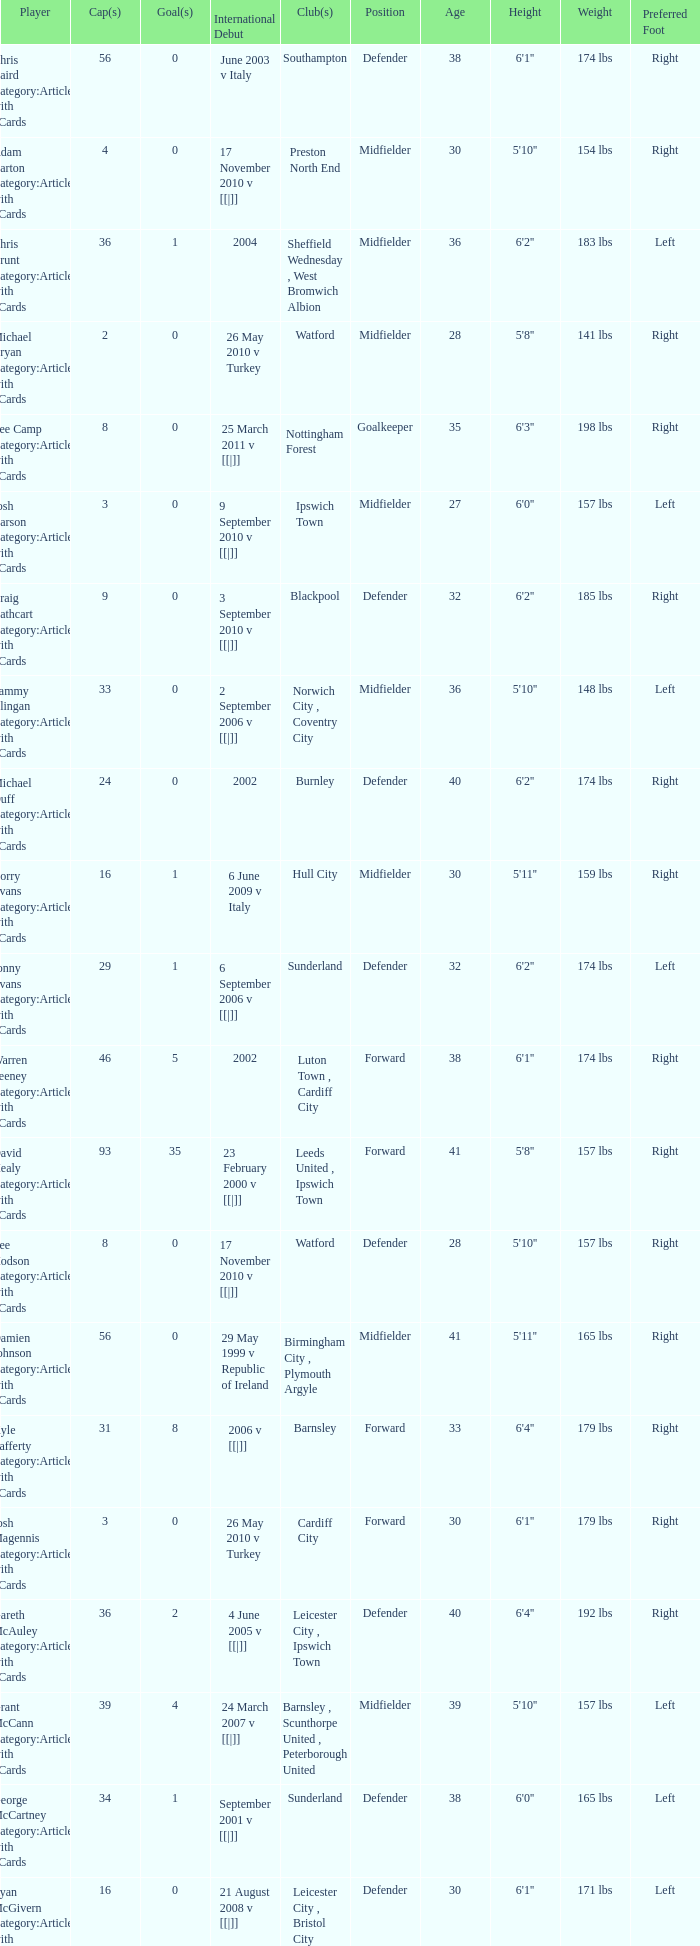Could you parse the entire table? {'header': ['Player', 'Cap(s)', 'Goal(s)', 'International Debut', 'Club(s)', 'Position', 'Age', 'Height', 'Weight', 'Preferred Foot'], 'rows': [['Chris Baird Category:Articles with hCards', '56', '0', 'June 2003 v Italy', 'Southampton', 'Defender', '38', "6'1''", '174 lbs', 'Right'], ['Adam Barton Category:Articles with hCards', '4', '0', '17 November 2010 v [[|]]', 'Preston North End', 'Midfielder', '30', "5'10''", '154 lbs', 'Right'], ['Chris Brunt Category:Articles with hCards', '36', '1', '2004', 'Sheffield Wednesday , West Bromwich Albion', 'Midfielder', '36', "6'2''", '183 lbs', 'Left'], ['Michael Bryan Category:Articles with hCards', '2', '0', '26 May 2010 v Turkey', 'Watford', 'Midfielder', '28', "5'8''", '141 lbs', 'Right'], ['Lee Camp Category:Articles with hCards', '8', '0', '25 March 2011 v [[|]]', 'Nottingham Forest', 'Goalkeeper', '35', "6'3''", '198 lbs', 'Right'], ['Josh Carson Category:Articles with hCards', '3', '0', '9 September 2010 v [[|]]', 'Ipswich Town', 'Midfielder', '27', "6'0''", '157 lbs', 'Left'], ['Craig Cathcart Category:Articles with hCards', '9', '0', '3 September 2010 v [[|]]', 'Blackpool', 'Defender', '32', "6'2''", '185 lbs', 'Right'], ['Sammy Clingan Category:Articles with hCards', '33', '0', '2 September 2006 v [[|]]', 'Norwich City , Coventry City', 'Midfielder', '36', "5'10''", '148 lbs', 'Left'], ['Michael Duff Category:Articles with hCards', '24', '0', '2002', 'Burnley', 'Defender', '40', "6'2''", '174 lbs', 'Right'], ['Corry Evans Category:Articles with hCards', '16', '1', '6 June 2009 v Italy', 'Hull City', 'Midfielder', '30', "5'11''", '159 lbs', 'Right'], ['Jonny Evans Category:Articles with hCards', '29', '1', '6 September 2006 v [[|]]', 'Sunderland', 'Defender', '32', "6'2''", '174 lbs', 'Left'], ['Warren Feeney Category:Articles with hCards', '46', '5', '2002', 'Luton Town , Cardiff City', 'Forward', '38', "6'1''", '174 lbs', 'Right'], ['David Healy Category:Articles with hCards', '93', '35', '23 February 2000 v [[|]]', 'Leeds United , Ipswich Town', 'Forward', '41', "5'8''", '157 lbs', 'Right'], ['Lee Hodson Category:Articles with hCards', '8', '0', '17 November 2010 v [[|]]', 'Watford', 'Defender', '28', "5'10''", '157 lbs', 'Right'], ['Damien Johnson Category:Articles with hCards', '56', '0', '29 May 1999 v Republic of Ireland', 'Birmingham City , Plymouth Argyle', 'Midfielder', '41', "5'11''", '165 lbs', 'Right'], ['Kyle Lafferty Category:Articles with hCards', '31', '8', '2006 v [[|]]', 'Barnsley', 'Forward', '33', "6'4''", '179 lbs', 'Right'], ['Josh Magennis Category:Articles with hCards', '3', '0', '26 May 2010 v Turkey', 'Cardiff City', 'Forward', '30', "6'1''", '179 lbs', 'Right'], ['Gareth McAuley Category:Articles with hCards', '36', '2', '4 June 2005 v [[|]]', 'Leicester City , Ipswich Town', 'Defender', '40', "6'4''", '192 lbs', 'Right'], ['Grant McCann Category:Articles with hCards', '39', '4', '24 March 2007 v [[|]]', 'Barnsley , Scunthorpe United , Peterborough United', 'Midfielder', '39', "5'10''", '157 lbs', 'Left'], ['George McCartney Category:Articles with hCards', '34', '1', 'September 2001 v [[|]]', 'Sunderland', 'Defender', '38', "6'0''", '165 lbs', 'Left'], ['Ryan McGivern Category:Articles with hCards', '16', '0', '21 August 2008 v [[|]]', 'Leicester City , Bristol City', 'Defender', '30', "6'1''", '171 lbs', 'Left'], ['James McPake Category:Articles with hCards', '1', '0', '2 June 2012 v [[|]]', 'Coventry City', 'Defender', '34', "6'3''", '181 lbs', 'Right'], ['Josh McQuoid Category:Articles with hCards', '5', '0', '17 November 2010 v [[|]]', 'Millwall', 'Forward', '28', "5'10''", '157 lbs', 'Right'], ['Oliver Norwood Category:Articles with hCards', '6', '0', '11 August 2010 v [[|]]', 'Coventry City', 'Midfielder', '30', "6'0''", '157 lbs', 'Right'], ["Michael O'Connor Category:Articles with hCards", '10', '0', '26 March 2008 v [[|]]', 'Scunthorpe United', 'Midfielder', '32', "5'10''", '157 lbs', 'Right'], ['Martin Paterson Category:Articles with hCards', '13', '0', '2007', 'Scunthorpe United , Burnley', 'Forward', '31', "5'11''", '174 lbs', 'Right'], ['Rory Patterson Category:Articles with hCards', '5', '1', '3 March 2010 v [[|]]', 'Plymouth Argyle', 'Forward', '36', "6'0''", '165 lbs', 'Right'], ['Dean Shiels Category:Articles with hCards', '9', '0', '15 November 2005 v [[|]]', 'Doncaster Rovers', 'Midfielder', '34', "5'11''", '148 lbs', 'Right'], ['Ivan Sproule Category:Articles with hCards', '11', '1', '7 September 2005 v England', 'Bristol City', 'Forward', '38', "5'10''", '157 lbs', 'Right'], ['Maik Taylor Category:Articles with hCards', '88', '0', '27 March 1999 v [[|]]', 'Birmingham City', 'Goalkeeper', '47', "6'4''", '190 lbs', 'Right'], ['Adam Thompson Category:Articles with hCards', '2', '0', '9 February 2011 v [[|]]', 'Watford', 'Defender', '26', "6'2''", '183 lbs', 'Right']]} How many caps figures are there for Norwich City, Coventry City? 1.0. 